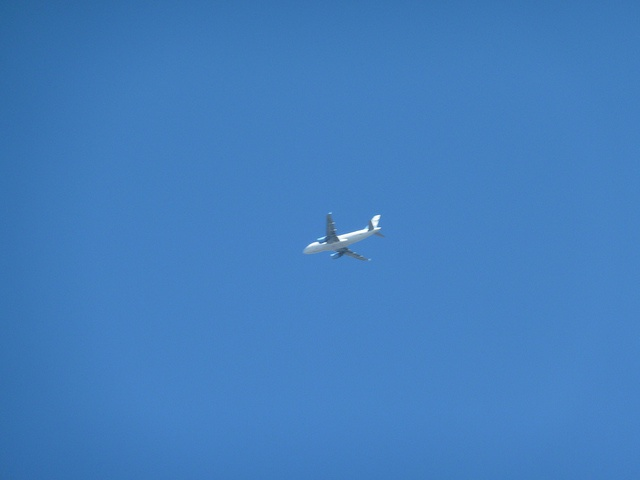Describe the objects in this image and their specific colors. I can see a airplane in blue, gray, and white tones in this image. 